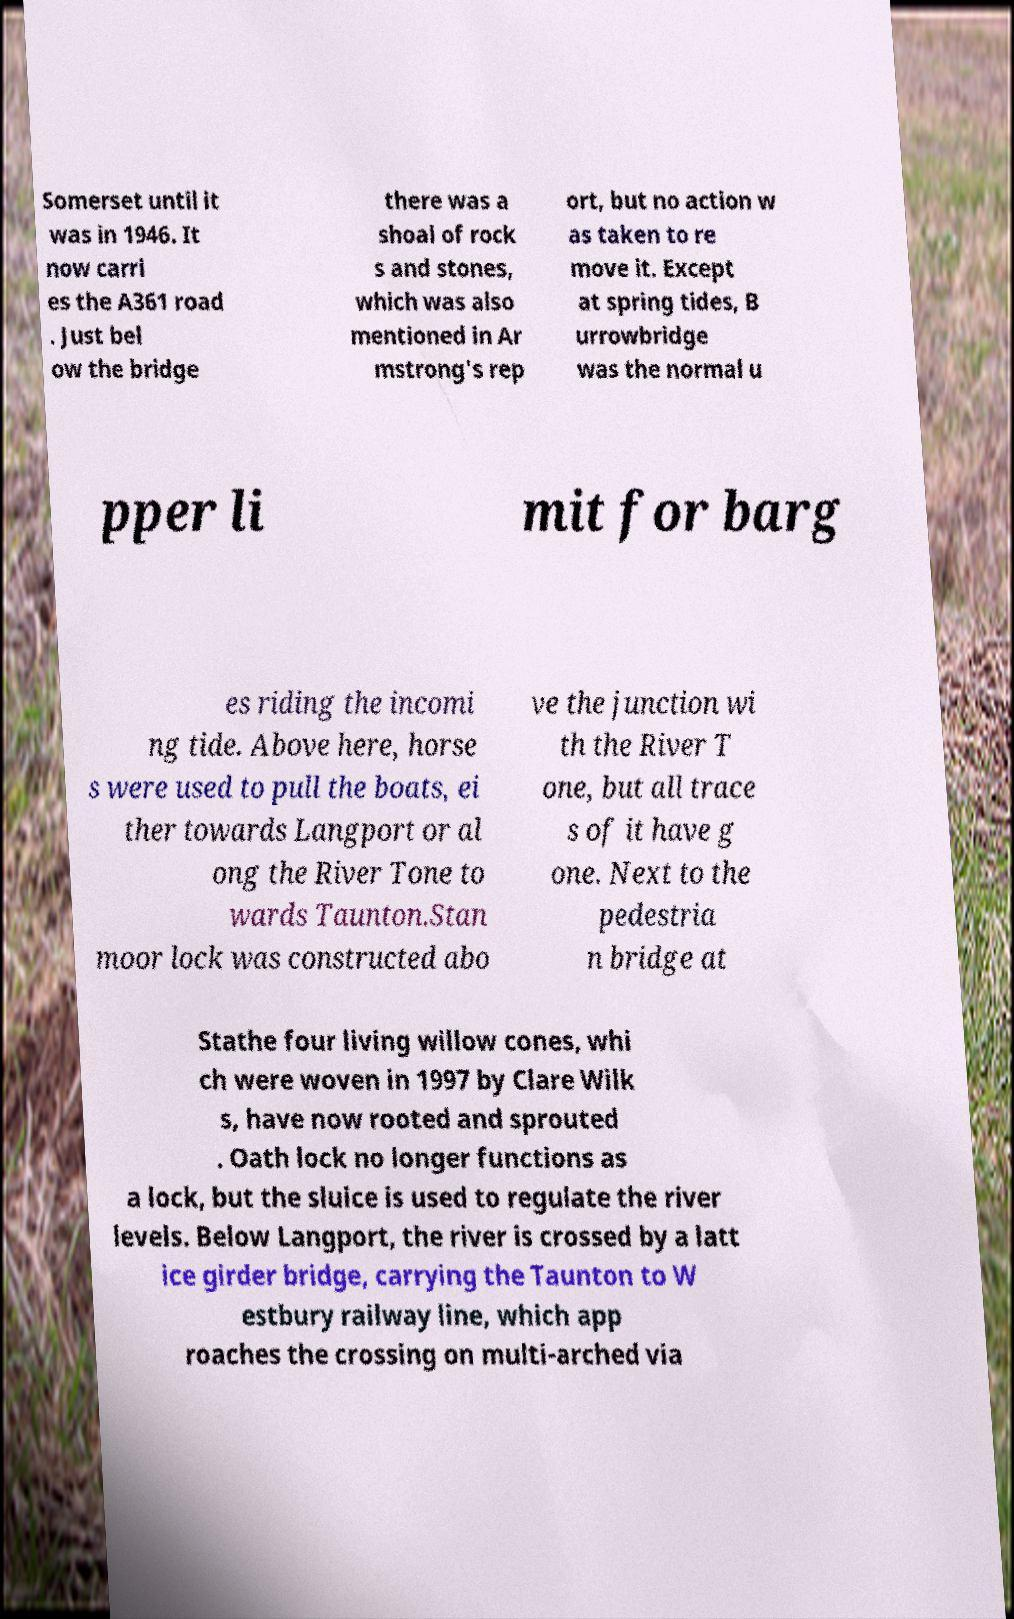Could you extract and type out the text from this image? Somerset until it was in 1946. It now carri es the A361 road . Just bel ow the bridge there was a shoal of rock s and stones, which was also mentioned in Ar mstrong's rep ort, but no action w as taken to re move it. Except at spring tides, B urrowbridge was the normal u pper li mit for barg es riding the incomi ng tide. Above here, horse s were used to pull the boats, ei ther towards Langport or al ong the River Tone to wards Taunton.Stan moor lock was constructed abo ve the junction wi th the River T one, but all trace s of it have g one. Next to the pedestria n bridge at Stathe four living willow cones, whi ch were woven in 1997 by Clare Wilk s, have now rooted and sprouted . Oath lock no longer functions as a lock, but the sluice is used to regulate the river levels. Below Langport, the river is crossed by a latt ice girder bridge, carrying the Taunton to W estbury railway line, which app roaches the crossing on multi-arched via 